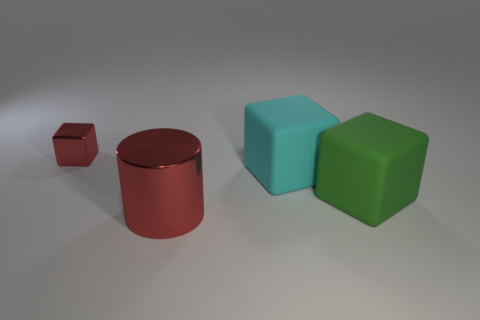Is there anything else that has the same shape as the large red thing?
Offer a terse response. No. Is the metallic cylinder the same color as the small object?
Offer a very short reply. Yes. What number of objects are large green objects or metal things to the left of the big red metallic cylinder?
Give a very brief answer. 2. Are there any green things that have the same size as the metal cylinder?
Ensure brevity in your answer.  Yes. Is the material of the large red object the same as the small cube?
Make the answer very short. Yes. How many things are small gray balls or large matte things?
Ensure brevity in your answer.  2. How big is the green matte block?
Keep it short and to the point. Large. Are there fewer tiny brown cubes than tiny metallic things?
Make the answer very short. Yes. What number of large metallic cylinders have the same color as the tiny metal object?
Keep it short and to the point. 1. There is a shiny object in front of the red metallic block; does it have the same color as the metallic block?
Your answer should be compact. Yes. 